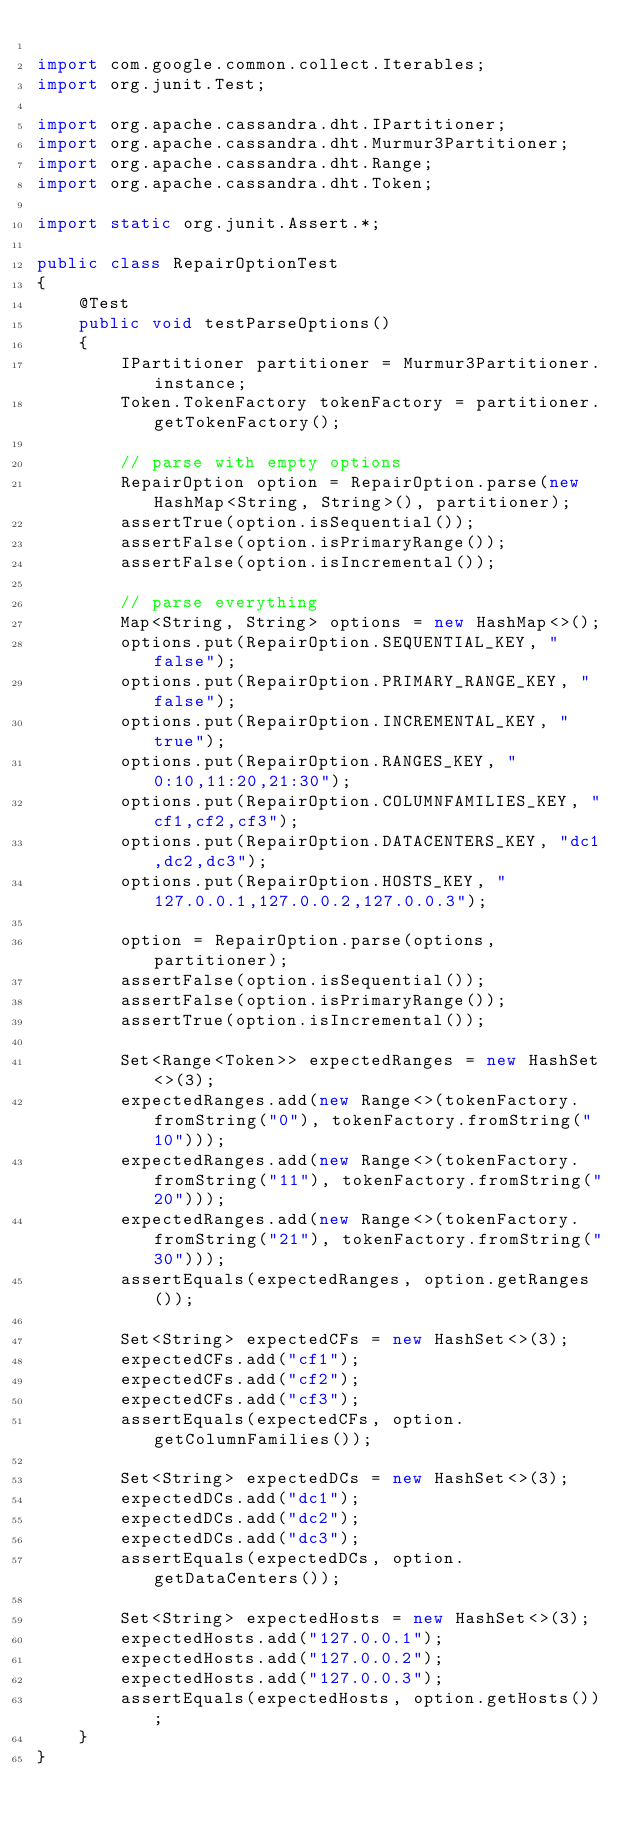<code> <loc_0><loc_0><loc_500><loc_500><_Java_>
import com.google.common.collect.Iterables;
import org.junit.Test;

import org.apache.cassandra.dht.IPartitioner;
import org.apache.cassandra.dht.Murmur3Partitioner;
import org.apache.cassandra.dht.Range;
import org.apache.cassandra.dht.Token;

import static org.junit.Assert.*;

public class RepairOptionTest
{
    @Test
    public void testParseOptions()
    {
        IPartitioner partitioner = Murmur3Partitioner.instance;
        Token.TokenFactory tokenFactory = partitioner.getTokenFactory();

        // parse with empty options
        RepairOption option = RepairOption.parse(new HashMap<String, String>(), partitioner);
        assertTrue(option.isSequential());
        assertFalse(option.isPrimaryRange());
        assertFalse(option.isIncremental());

        // parse everything
        Map<String, String> options = new HashMap<>();
        options.put(RepairOption.SEQUENTIAL_KEY, "false");
        options.put(RepairOption.PRIMARY_RANGE_KEY, "false");
        options.put(RepairOption.INCREMENTAL_KEY, "true");
        options.put(RepairOption.RANGES_KEY, "0:10,11:20,21:30");
        options.put(RepairOption.COLUMNFAMILIES_KEY, "cf1,cf2,cf3");
        options.put(RepairOption.DATACENTERS_KEY, "dc1,dc2,dc3");
        options.put(RepairOption.HOSTS_KEY, "127.0.0.1,127.0.0.2,127.0.0.3");

        option = RepairOption.parse(options, partitioner);
        assertFalse(option.isSequential());
        assertFalse(option.isPrimaryRange());
        assertTrue(option.isIncremental());

        Set<Range<Token>> expectedRanges = new HashSet<>(3);
        expectedRanges.add(new Range<>(tokenFactory.fromString("0"), tokenFactory.fromString("10")));
        expectedRanges.add(new Range<>(tokenFactory.fromString("11"), tokenFactory.fromString("20")));
        expectedRanges.add(new Range<>(tokenFactory.fromString("21"), tokenFactory.fromString("30")));
        assertEquals(expectedRanges, option.getRanges());

        Set<String> expectedCFs = new HashSet<>(3);
        expectedCFs.add("cf1");
        expectedCFs.add("cf2");
        expectedCFs.add("cf3");
        assertEquals(expectedCFs, option.getColumnFamilies());

        Set<String> expectedDCs = new HashSet<>(3);
        expectedDCs.add("dc1");
        expectedDCs.add("dc2");
        expectedDCs.add("dc3");
        assertEquals(expectedDCs, option.getDataCenters());

        Set<String> expectedHosts = new HashSet<>(3);
        expectedHosts.add("127.0.0.1");
        expectedHosts.add("127.0.0.2");
        expectedHosts.add("127.0.0.3");
        assertEquals(expectedHosts, option.getHosts());
    }
}
</code> 